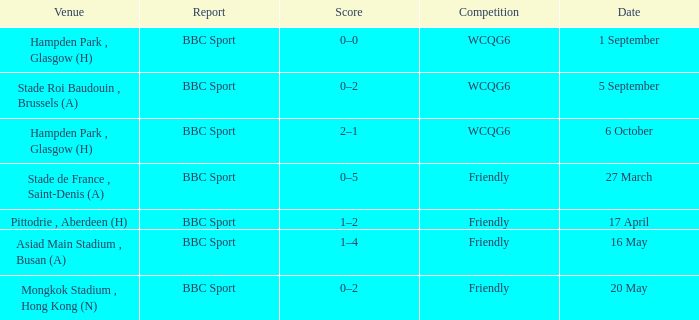Who reported the game on 6 october? BBC Sport. 